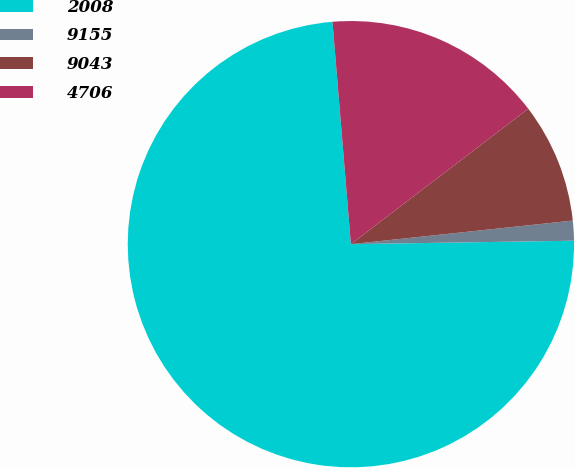<chart> <loc_0><loc_0><loc_500><loc_500><pie_chart><fcel>2008<fcel>9155<fcel>9043<fcel>4706<nl><fcel>73.93%<fcel>1.44%<fcel>8.69%<fcel>15.94%<nl></chart> 